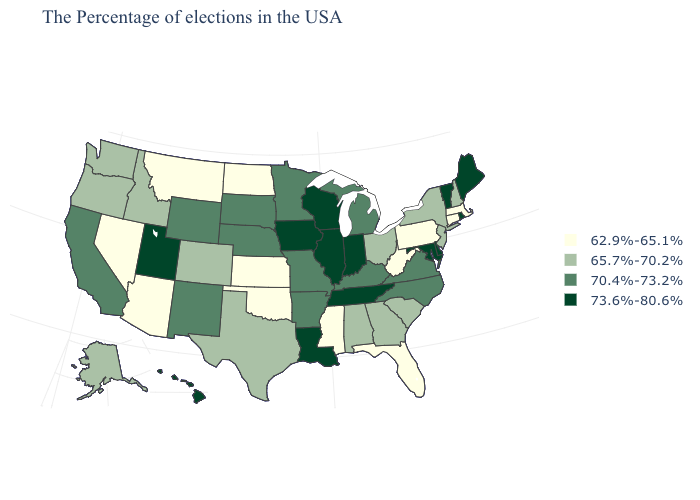What is the value of New Hampshire?
Quick response, please. 65.7%-70.2%. Name the states that have a value in the range 73.6%-80.6%?
Short answer required. Maine, Rhode Island, Vermont, Delaware, Maryland, Indiana, Tennessee, Wisconsin, Illinois, Louisiana, Iowa, Utah, Hawaii. Name the states that have a value in the range 73.6%-80.6%?
Keep it brief. Maine, Rhode Island, Vermont, Delaware, Maryland, Indiana, Tennessee, Wisconsin, Illinois, Louisiana, Iowa, Utah, Hawaii. Name the states that have a value in the range 70.4%-73.2%?
Write a very short answer. Virginia, North Carolina, Michigan, Kentucky, Missouri, Arkansas, Minnesota, Nebraska, South Dakota, Wyoming, New Mexico, California. What is the highest value in states that border Nevada?
Answer briefly. 73.6%-80.6%. What is the lowest value in the South?
Write a very short answer. 62.9%-65.1%. What is the value of Louisiana?
Concise answer only. 73.6%-80.6%. Does Nebraska have a higher value than Wisconsin?
Be succinct. No. How many symbols are there in the legend?
Give a very brief answer. 4. Among the states that border Minnesota , which have the lowest value?
Concise answer only. North Dakota. Does Mississippi have the same value as Idaho?
Write a very short answer. No. What is the value of Louisiana?
Quick response, please. 73.6%-80.6%. Which states have the highest value in the USA?
Quick response, please. Maine, Rhode Island, Vermont, Delaware, Maryland, Indiana, Tennessee, Wisconsin, Illinois, Louisiana, Iowa, Utah, Hawaii. What is the value of Arkansas?
Short answer required. 70.4%-73.2%. Which states have the lowest value in the USA?
Keep it brief. Massachusetts, Connecticut, Pennsylvania, West Virginia, Florida, Mississippi, Kansas, Oklahoma, North Dakota, Montana, Arizona, Nevada. 